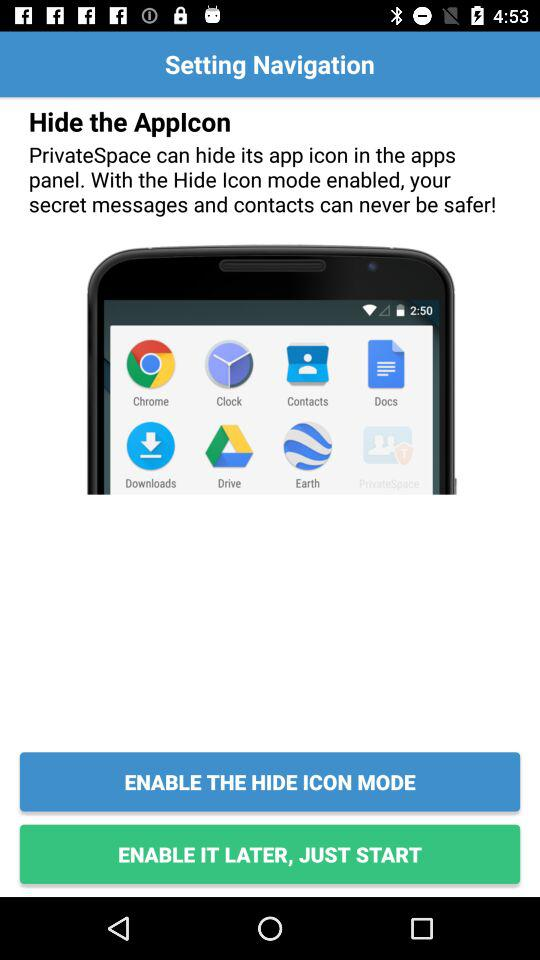Which app can hide its icon from the apps panel? The app that can hide its icon from the apps panel is "PrivateSpace". 